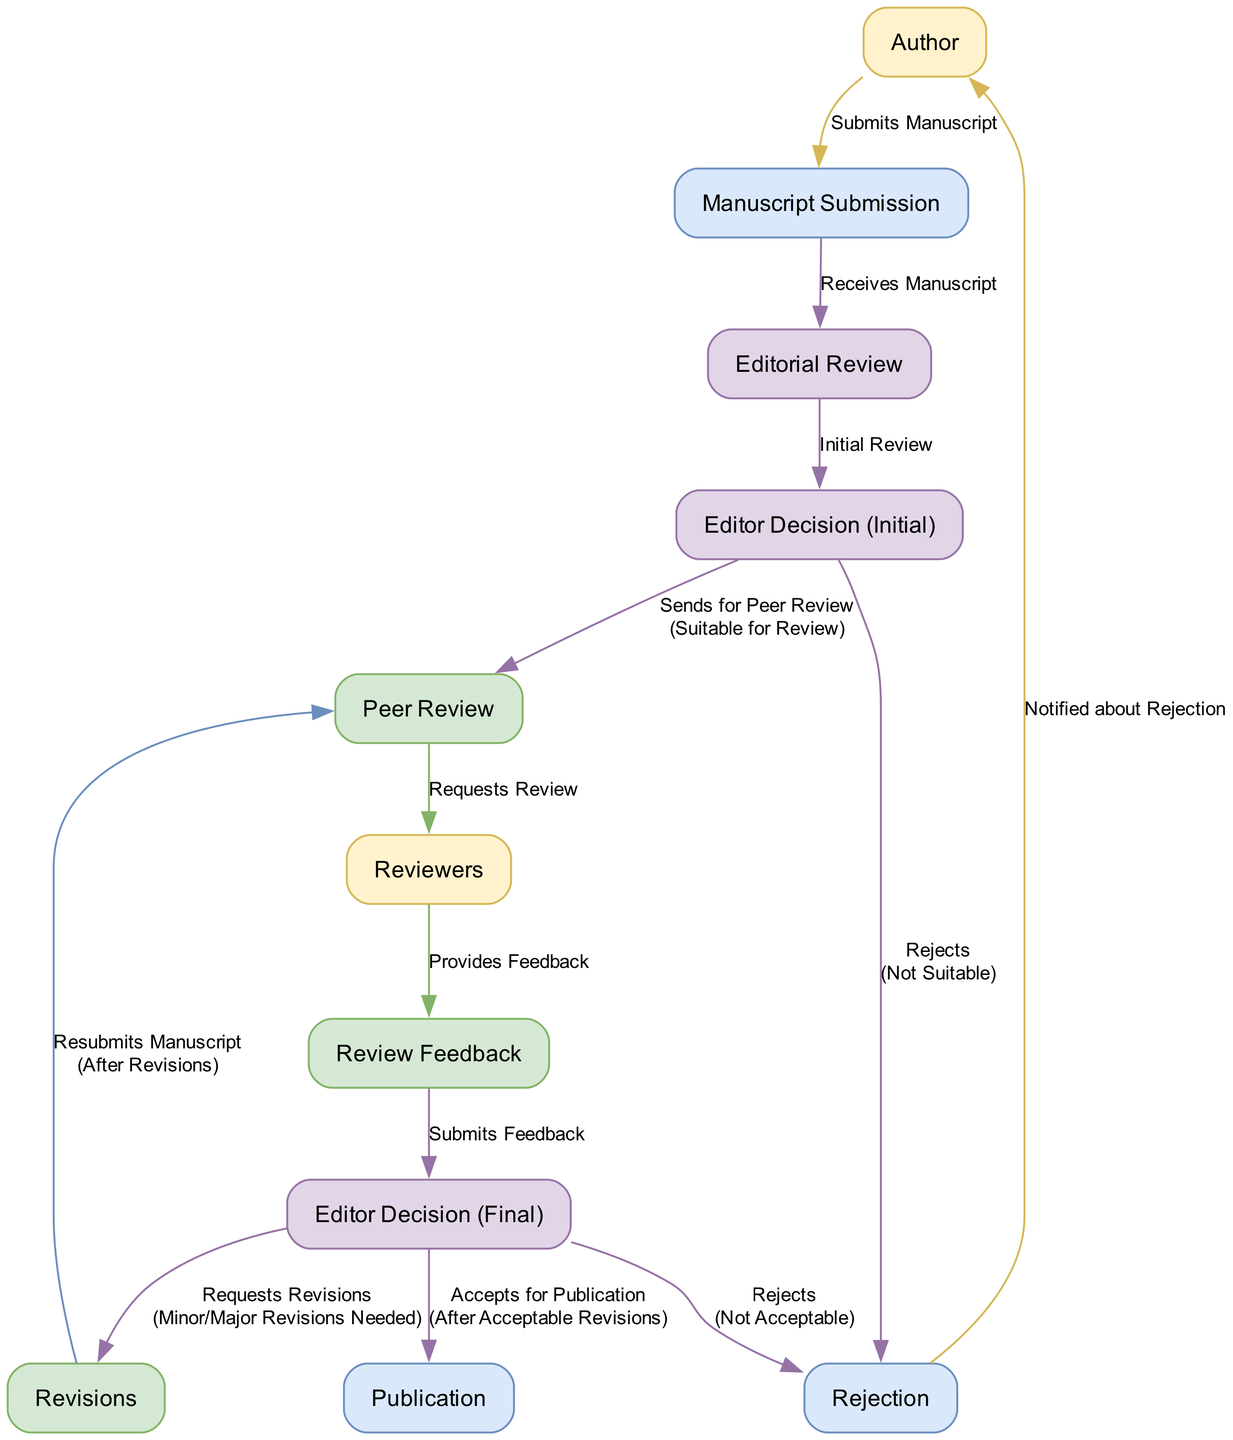What is the first step in the peer review process? The first step is the "Manuscript Submission", where the author submits their manuscript for consideration.
Answer: Manuscript Submission How many nodes are there in the diagram? The diagram contains a total of 11 nodes, each representing different entities or steps in the peer review process.
Answer: 11 What happens if the editor decides the submission is not suitable? If the editor decides that the submission is not suitable, it is marked for "Rejection".
Answer: Rejection Who provides feedback during the peer review process? The "Reviewers" are the ones who provide feedback on the manuscript after reviewing it.
Answer: Reviewers What action does the editor take after receiving reviewer feedback? After receiving the reviewer feedback, the editor decides whether to request revisions or to reject the manuscript altogether.
Answer: Editor Decision (Final) Which step follows the publication of a manuscript? There are no steps that follow the publication of a manuscript; "Publication" is the final step in the process.
Answer: None What condition leads to a manuscript being sent for peer review? The manuscript is sent for peer review if the editor deems it "Suitable for Review".
Answer: Suitable for Review What must authors do after receiving requests for revisions? Authors must make the necessary changes and then "Resubmit Manuscript" to the peer review process after completing the revisions.
Answer: Resubmits Manuscript What color represents the nodes related to the authors? The nodes related to authors are represented with a fill color of light yellow, specifically #FFF2CC.
Answer: Light Yellow 